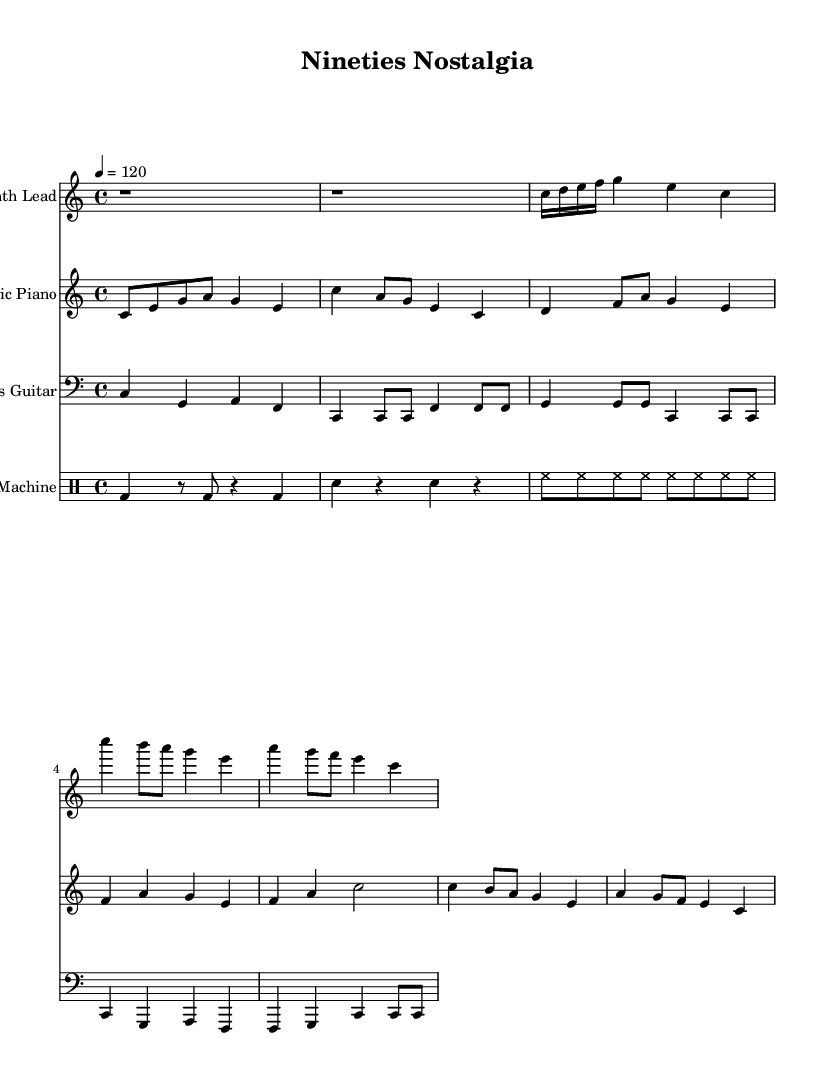What is the key signature of this music? The key signature is indicated at the beginning of the score, showing that it is in C major, which has no sharps or flats.
Answer: C major What is the time signature of the piece? The time signature is presented as a fraction at the beginning of the score, indicating that the music is in 4/4 time, meaning there are four beats in each measure.
Answer: 4/4 What is the tempo marking for this piece? The tempo marking is shown in the score as a quarter note value paired with a number (4 = 120), indicating that the beats are counted in quarter notes at a speed of 120 beats per minute.
Answer: 120 How many measures are there in the synth lead section? By counting the vertical bar lines in the synth lead part, we can see that it has a total of four measures, each ending with a bar line.
Answer: 4 What instruments are included in this score? The score lists the instruments at the beginning of each staff, which are "Synth Lead," "Electric Piano," "Bass Guitar," and "Drum Machine."
Answer: Synth Lead, Electric Piano, Bass Guitar, Drum Machine Which instrument has a bass clef? Looking at the staff designations, the "Bass Guitar" part is designated with a bass clef at the beginning of its staff, indicating it plays lower-pitched notes.
Answer: Bass Guitar What rhythmic pattern does the drum machine use? The drum machine section displays a specific rhythmic pattern, combining bass drum and snare hits with eight notes of hi-hat, creating a consistent dance beat characteristic of dance-pop music.
Answer: Dance beat 